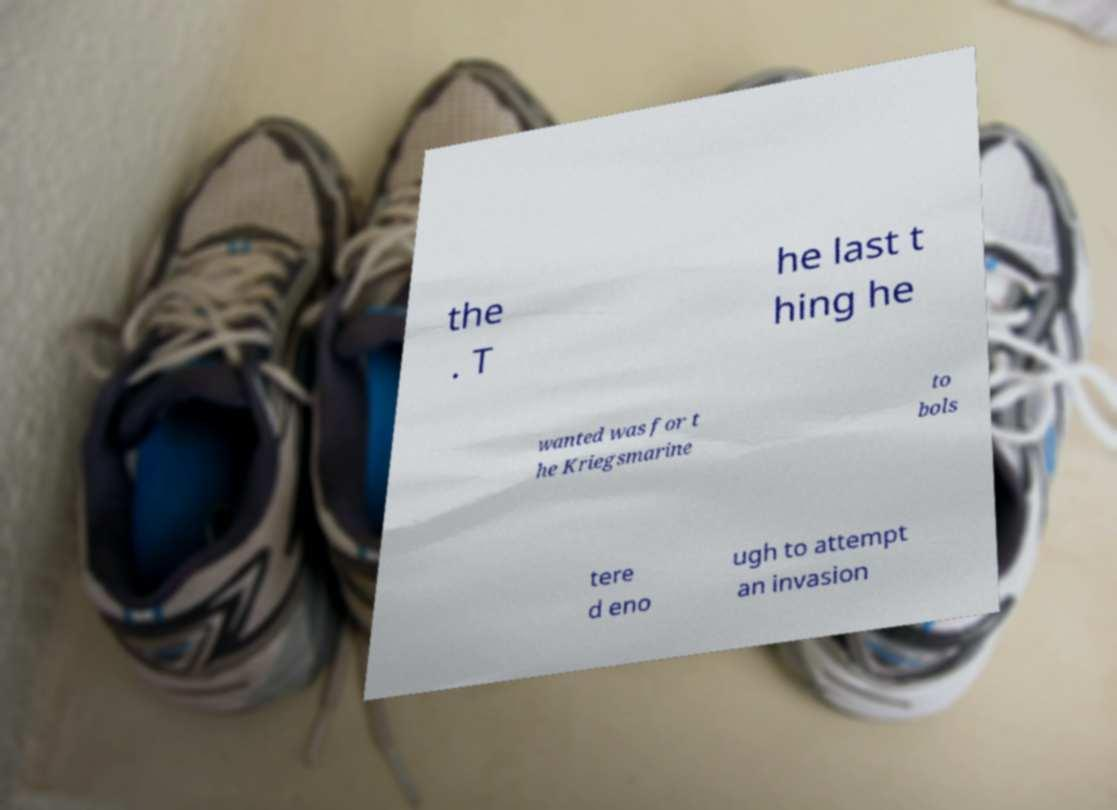Please identify and transcribe the text found in this image. the . T he last t hing he wanted was for t he Kriegsmarine to bols tere d eno ugh to attempt an invasion 